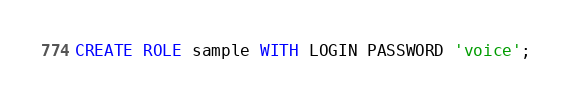Convert code to text. <code><loc_0><loc_0><loc_500><loc_500><_SQL_>CREATE ROLE sample WITH LOGIN PASSWORD 'voice';
</code> 